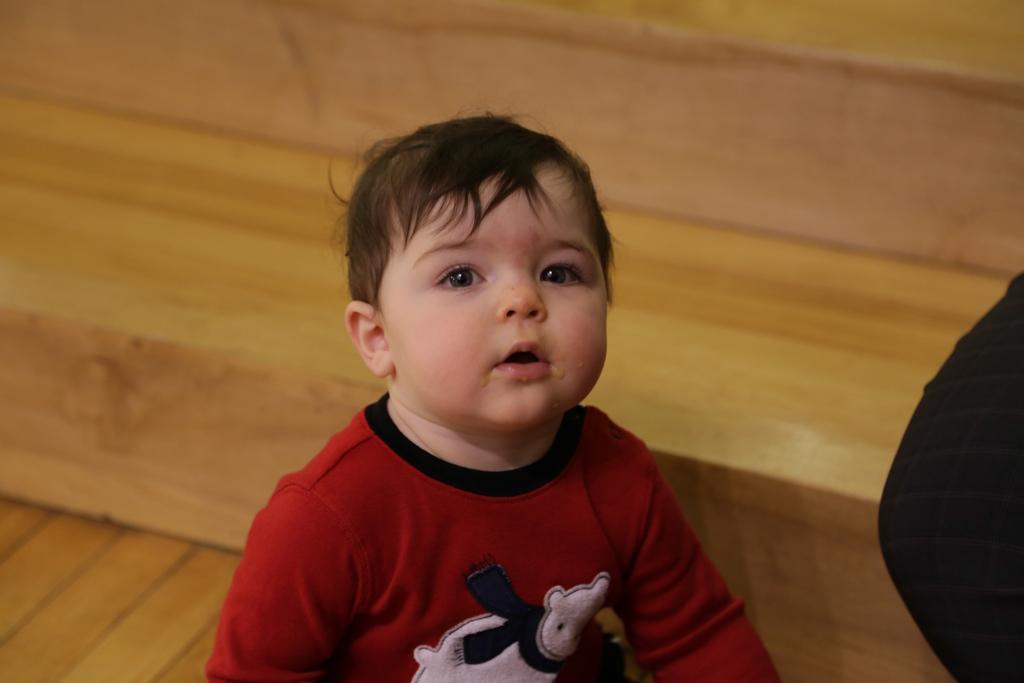Please provide a concise description of this image. In this picture there is a boy. In the background of the image we can see wooden surface. On the right side of the image we can see black object. 